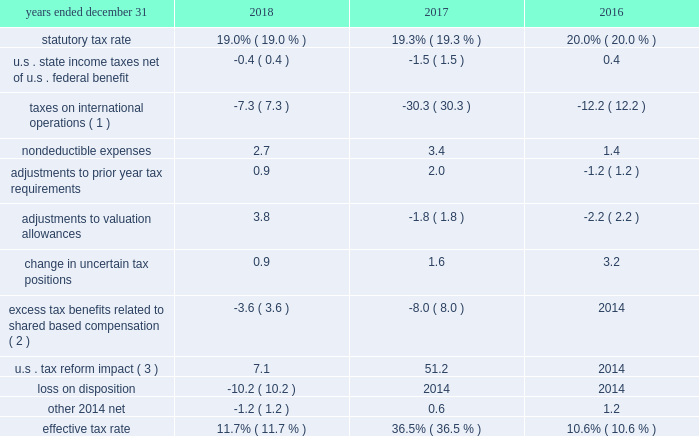
( 1 ) the company determines the adjustment for taxes on international operations based on the difference between the statutory tax rate applicable to earnings in each foreign jurisdiction and the enacted rate of 19.0% ( 19.0 % ) , 19.3% ( 19.3 % ) and 20.0% ( 20.0 % ) at december 31 , 2018 , 2017 , and 2016 , respectively .
The benefit to the company 2019s effective income tax rate from taxes on international operations relates to benefits from lower-taxed global operations , primarily due to the use of global funding structures and the tax holiday in singapore .
The impact decreased from 2017 to 2018 primarily as a result of the decrease in the u.s .
Federal tax ( 2 ) with the adoption of asu 2016-09 in 2017 , excess tax benefits and deficiencies from share-based payment transactions are recognized as income tax expense or benefit in the company 2019s consolidated statements of income .
( 3 ) the impact of the tax reform act including the transition tax , the re-measurement of u.s .
Deferred tax assets and liabilities from 35% ( 35 % ) to 21% ( 21 % ) , withholding tax accruals , and the allocation of tax benefit between continuing operations and discontinued operations related to utilization of foreign tax credits. .
What is the difference between the statutory tax rate and the effective tax rate for international operations in 2018? 
Computations: (36.5% - 19.3%)
Answer: 0.172. 